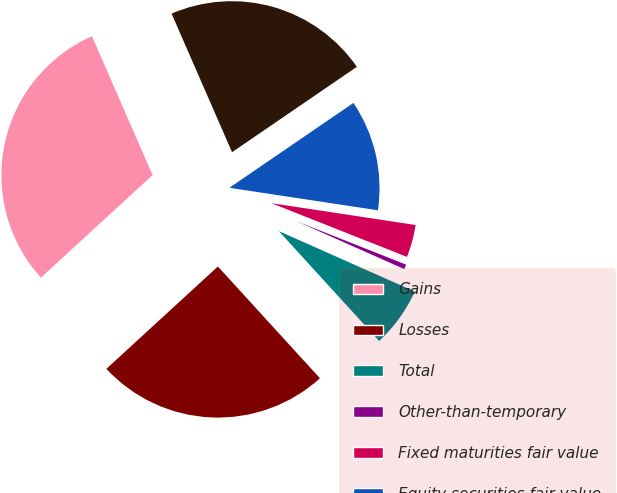Convert chart. <chart><loc_0><loc_0><loc_500><loc_500><pie_chart><fcel>Gains<fcel>Losses<fcel>Total<fcel>Other-than-temporary<fcel>Fixed maturities fair value<fcel>Equity securities fair value<fcel>Total net realized capital<nl><fcel>30.27%<fcel>24.96%<fcel>6.57%<fcel>0.65%<fcel>3.61%<fcel>11.94%<fcel>22.0%<nl></chart> 